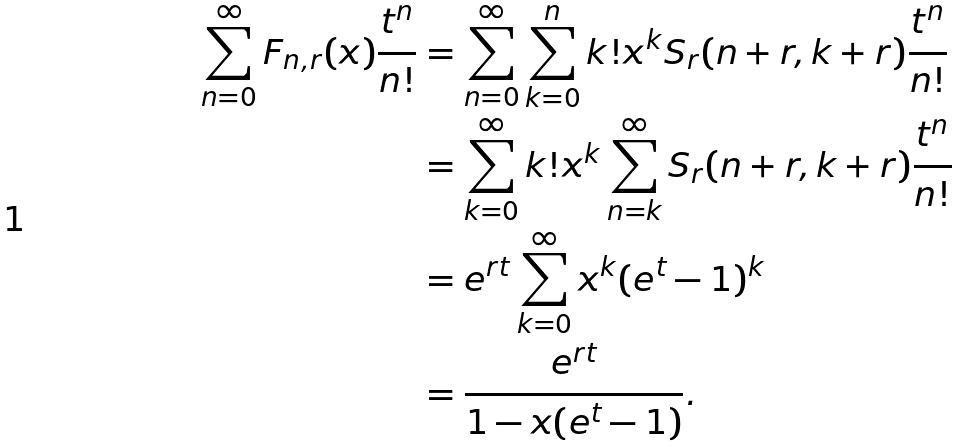Convert formula to latex. <formula><loc_0><loc_0><loc_500><loc_500>\sum _ { n = 0 } ^ { \infty } F _ { n , r } ( x ) \frac { t ^ { n } } { n ! } & = \sum _ { n = 0 } ^ { \infty } \sum _ { k = 0 } ^ { n } k ! x ^ { k } S _ { r } ( n + r , k + r ) \frac { t ^ { n } } { n ! } \\ & = \sum _ { k = 0 } ^ { \infty } k ! x ^ { k } \sum _ { n = k } ^ { \infty } S _ { r } ( n + r , k + r ) \frac { t ^ { n } } { n ! } \\ & = e ^ { r t } \sum _ { k = 0 } ^ { \infty } x ^ { k } ( e ^ { t } - 1 ) ^ { k } \\ & = \frac { e ^ { r t } } { 1 - x ( e ^ { t } - 1 ) } .</formula> 